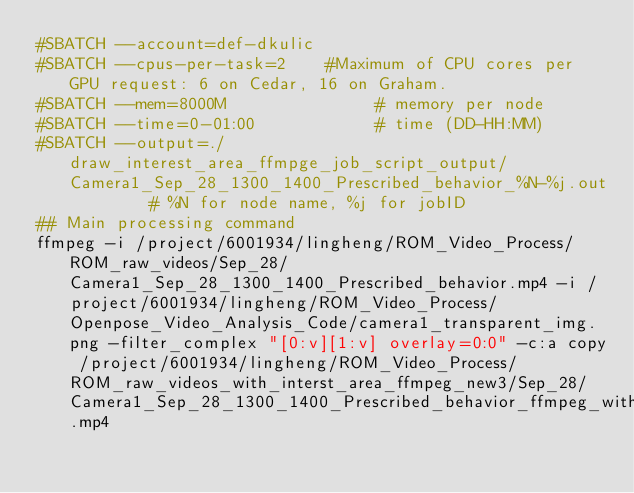Convert code to text. <code><loc_0><loc_0><loc_500><loc_500><_Bash_>#SBATCH --account=def-dkulic
#SBATCH --cpus-per-task=2    #Maximum of CPU cores per GPU request: 6 on Cedar, 16 on Graham.
#SBATCH --mem=8000M               # memory per node
#SBATCH --time=0-01:00            # time (DD-HH:MM)
#SBATCH --output=./draw_interest_area_ffmpge_job_script_output/Camera1_Sep_28_1300_1400_Prescribed_behavior_%N-%j.out        # %N for node name, %j for jobID
## Main processing command
ffmpeg -i /project/6001934/lingheng/ROM_Video_Process/ROM_raw_videos/Sep_28/Camera1_Sep_28_1300_1400_Prescribed_behavior.mp4 -i /project/6001934/lingheng/ROM_Video_Process/Openpose_Video_Analysis_Code/camera1_transparent_img.png -filter_complex "[0:v][1:v] overlay=0:0" -c:a copy /project/6001934/lingheng/ROM_Video_Process/ROM_raw_videos_with_interst_area_ffmpeg_new3/Sep_28/Camera1_Sep_28_1300_1400_Prescribed_behavior_ffmpeg_with_interest_area.mp4</code> 